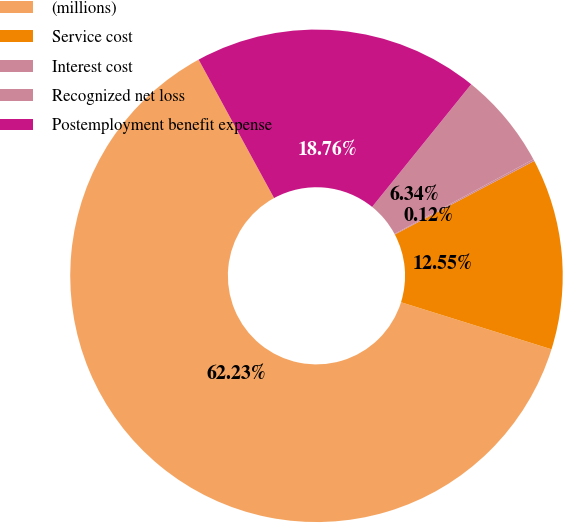<chart> <loc_0><loc_0><loc_500><loc_500><pie_chart><fcel>(millions)<fcel>Service cost<fcel>Interest cost<fcel>Recognized net loss<fcel>Postemployment benefit expense<nl><fcel>62.24%<fcel>12.55%<fcel>0.12%<fcel>6.34%<fcel>18.76%<nl></chart> 